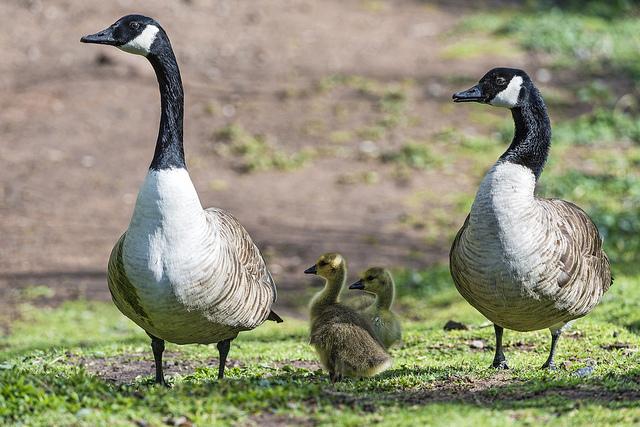What species of animal is this?
Be succinct. Goose. Are the birds watching a predator?
Write a very short answer. No. Are there any baby birds on the ground?
Be succinct. Yes. 